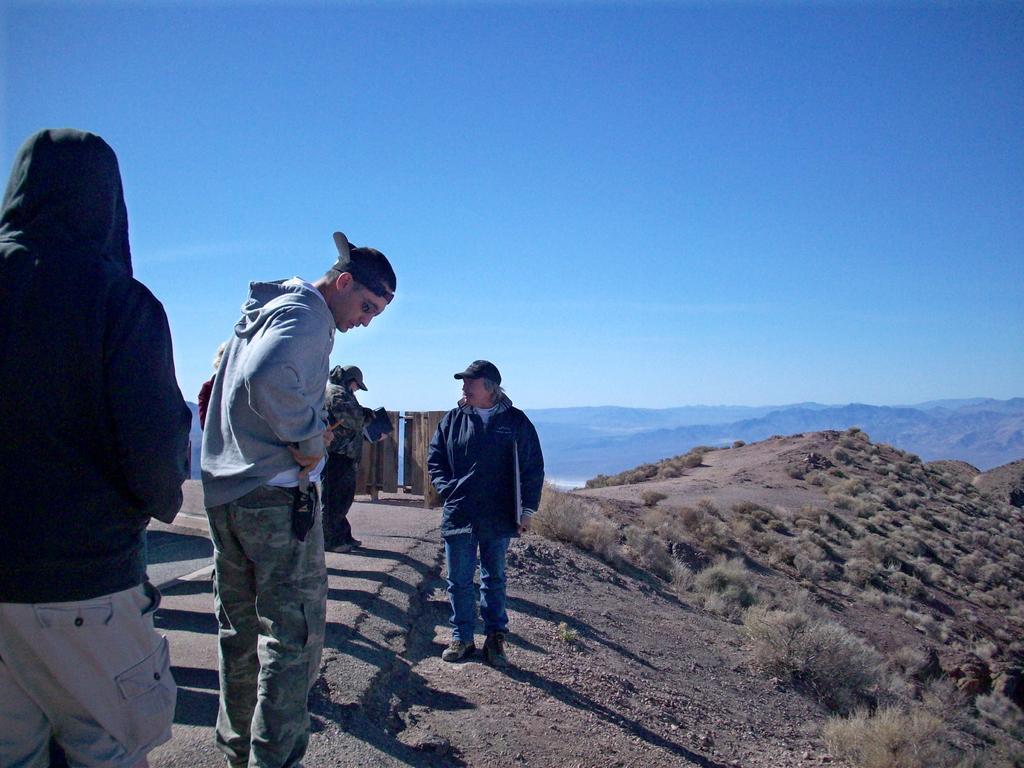In one or two sentences, can you explain what this image depicts? In this image I can see the group of people with different color dresses. To the right I can see the grass. In the background I can see the mountains and the sky. 